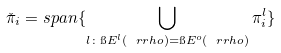Convert formula to latex. <formula><loc_0><loc_0><loc_500><loc_500>\check { \pi } _ { i } = s p a n \{ \bigcup _ { l \colon \i E ^ { l } ( \ r r h o ) = \i E ^ { o } ( \ r r h o ) } \pi ^ { l } _ { i } \}</formula> 